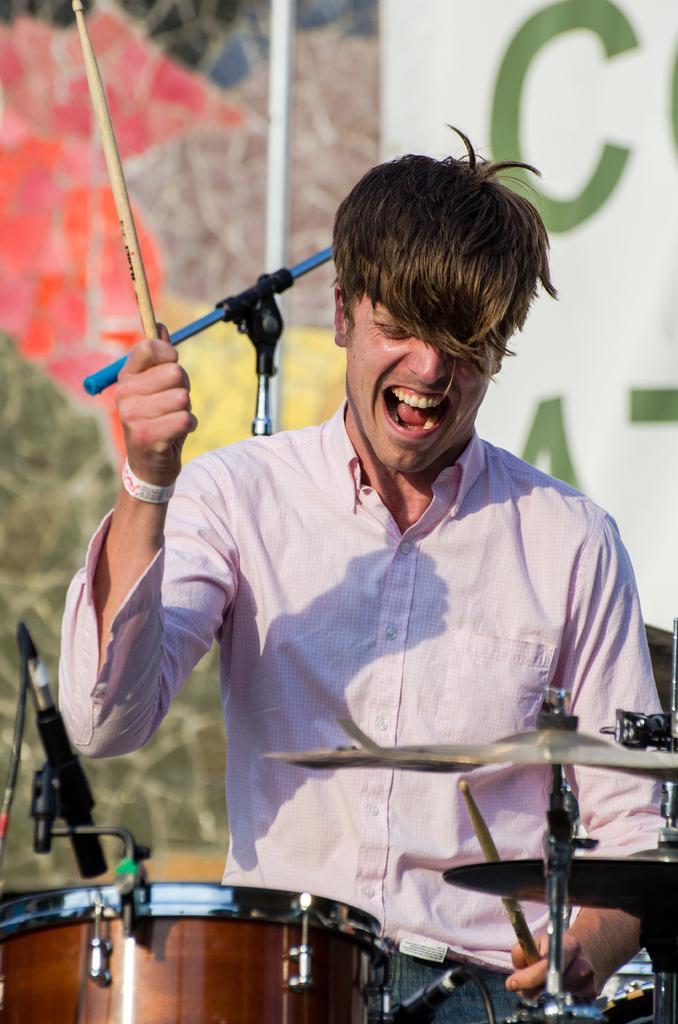In one or two sentences, can you explain what this image depicts? In the front of the image I can see a person is holding sticks. In-front of that person there are musical instruments. In the background of the image there is a pole, banner, mic stand and wall. 